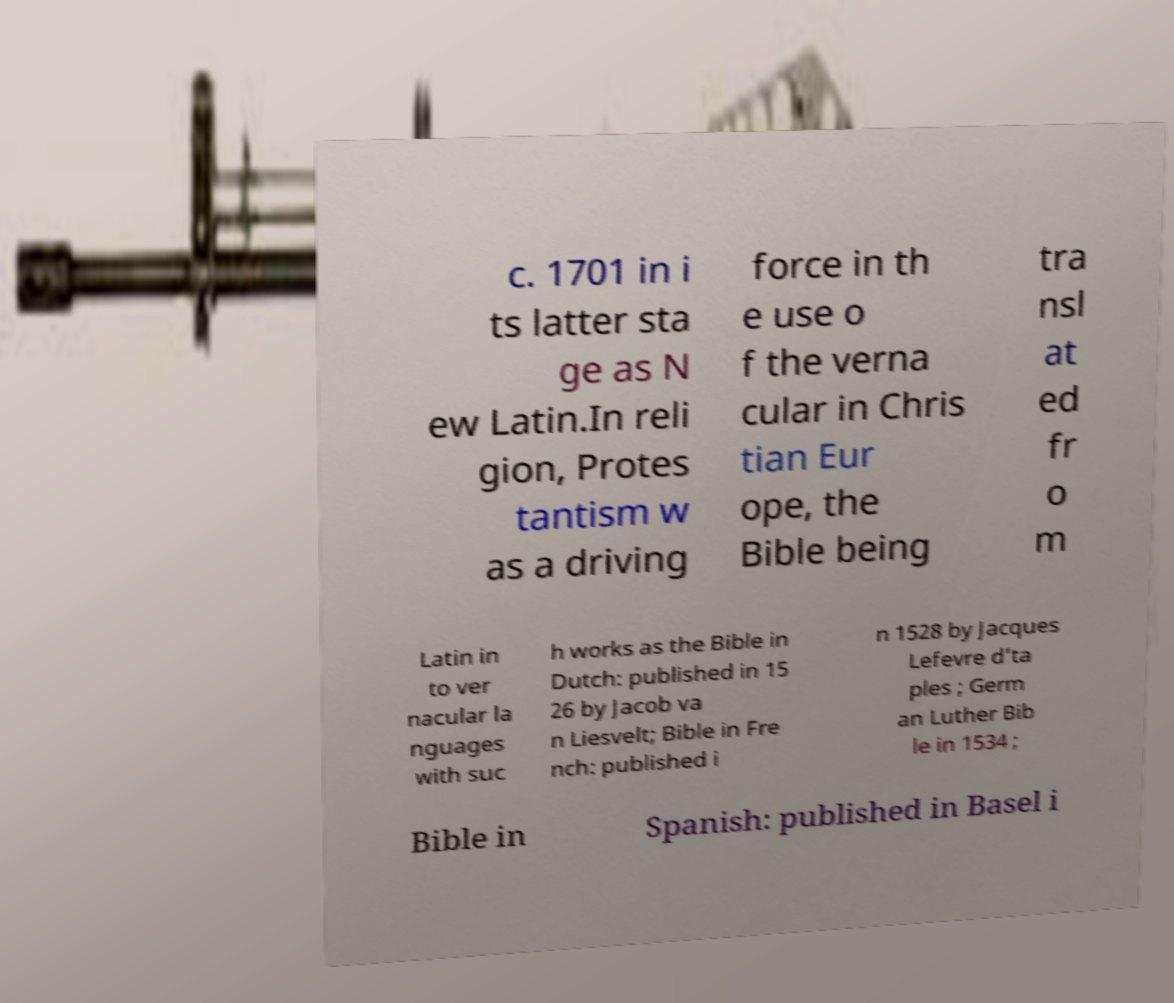There's text embedded in this image that I need extracted. Can you transcribe it verbatim? c. 1701 in i ts latter sta ge as N ew Latin.In reli gion, Protes tantism w as a driving force in th e use o f the verna cular in Chris tian Eur ope, the Bible being tra nsl at ed fr o m Latin in to ver nacular la nguages with suc h works as the Bible in Dutch: published in 15 26 by Jacob va n Liesvelt; Bible in Fre nch: published i n 1528 by Jacques Lefevre d’ta ples ; Germ an Luther Bib le in 1534 ; Bible in Spanish: published in Basel i 